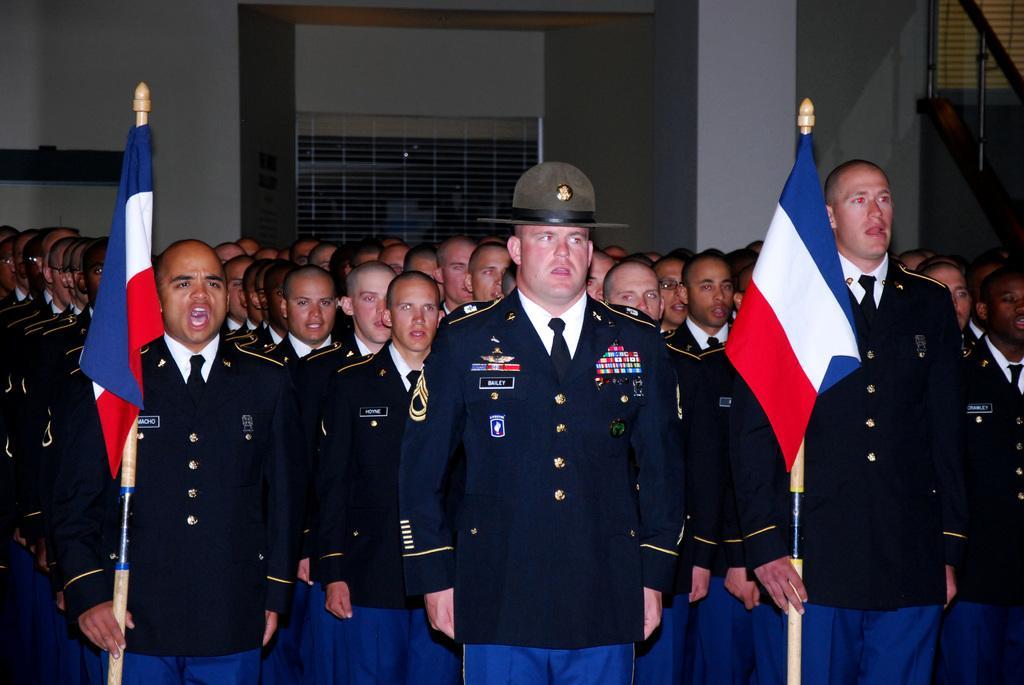How would you summarize this image in a sentence or two? In this picture there are people standing, among them there are two men holding flag poles. In the background of the image we can see wall, railing and objects. 